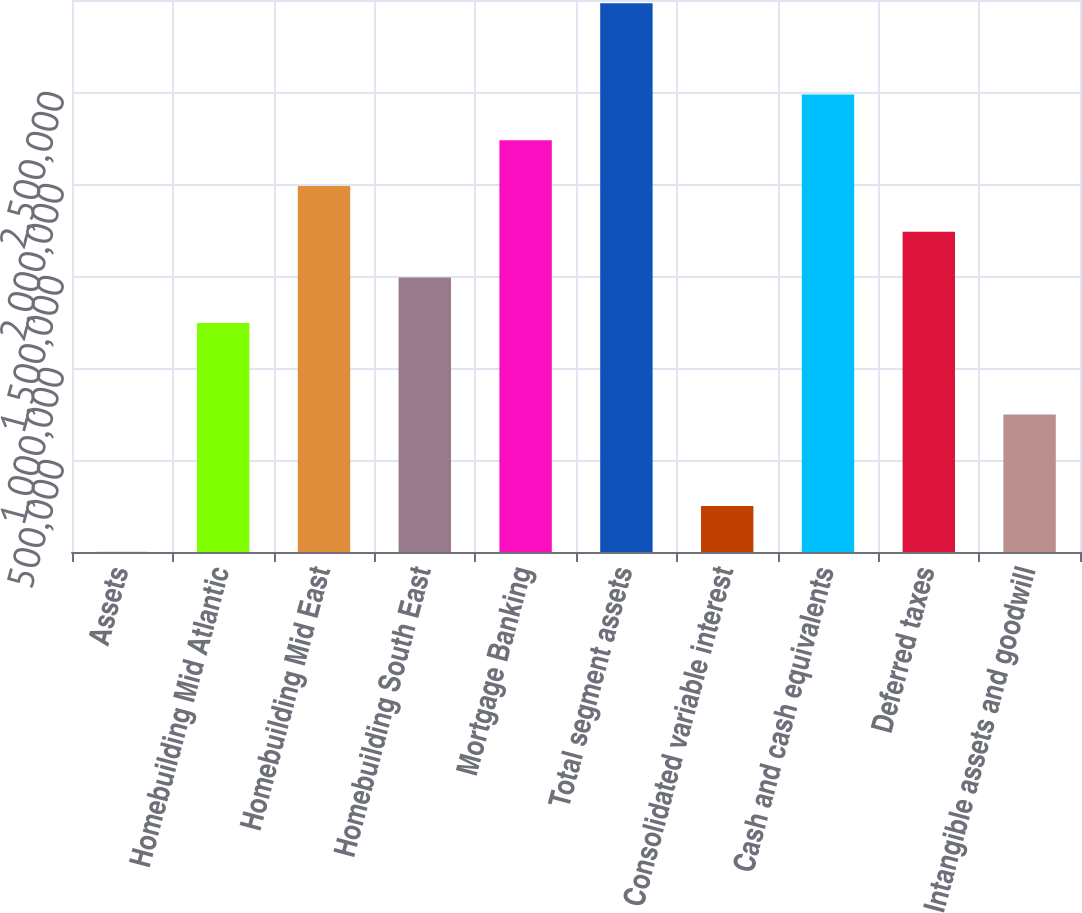Convert chart. <chart><loc_0><loc_0><loc_500><loc_500><bar_chart><fcel>Assets<fcel>Homebuilding Mid Atlantic<fcel>Homebuilding Mid East<fcel>Homebuilding South East<fcel>Mortgage Banking<fcel>Total segment assets<fcel>Consolidated variable interest<fcel>Cash and cash equivalents<fcel>Deferred taxes<fcel>Intangible assets and goodwill<nl><fcel>2013<fcel>1.24408e+06<fcel>1.98932e+06<fcel>1.49249e+06<fcel>2.23773e+06<fcel>2.98298e+06<fcel>250426<fcel>2.48615e+06<fcel>1.74091e+06<fcel>747254<nl></chart> 